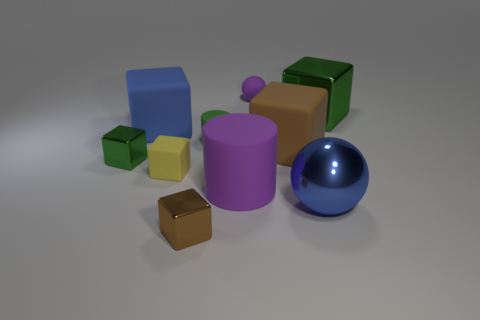Subtract 2 cubes. How many cubes are left? 4 Subtract all tiny yellow rubber cubes. How many cubes are left? 5 Subtract all brown blocks. How many blocks are left? 4 Subtract all gray cubes. Subtract all red cylinders. How many cubes are left? 6 Subtract all tiny yellow matte cubes. Subtract all tiny things. How many objects are left? 4 Add 6 large balls. How many large balls are left? 7 Add 1 yellow blocks. How many yellow blocks exist? 2 Subtract 1 blue blocks. How many objects are left? 9 Subtract all cubes. How many objects are left? 4 